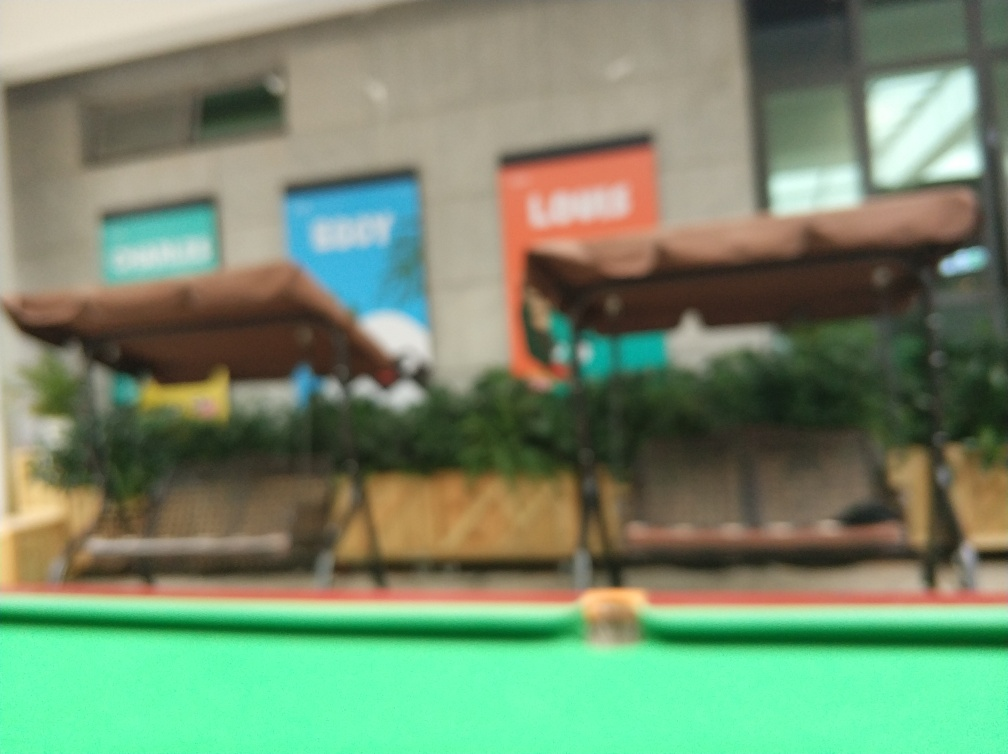Can you describe the setting or location depicted in the image despite the blurriness? While specific details are indiscernible due to the blur, the image suggests an open, public space, likely outdoors. There are structures that might be canopies or umbrellas, indicative of a seating area. Greenery is present, and there are storefronts in the distance with signs that, although unreadable, convey a sense of a commercial area. The overall impression is of a place where people might gather, perhaps a market or restaurant patio. 